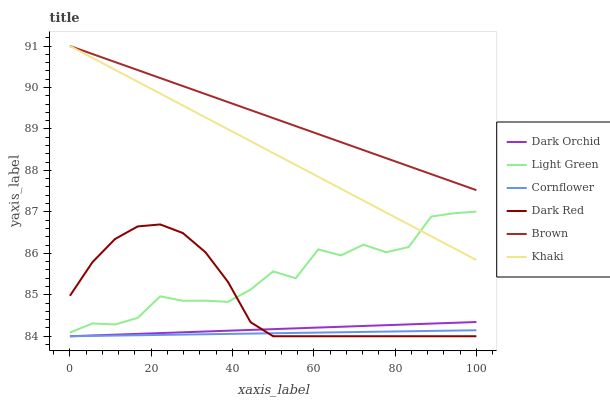Does Cornflower have the minimum area under the curve?
Answer yes or no. Yes. Does Brown have the maximum area under the curve?
Answer yes or no. Yes. Does Khaki have the minimum area under the curve?
Answer yes or no. No. Does Khaki have the maximum area under the curve?
Answer yes or no. No. Is Dark Orchid the smoothest?
Answer yes or no. Yes. Is Light Green the roughest?
Answer yes or no. Yes. Is Khaki the smoothest?
Answer yes or no. No. Is Khaki the roughest?
Answer yes or no. No. Does Cornflower have the lowest value?
Answer yes or no. Yes. Does Khaki have the lowest value?
Answer yes or no. No. Does Khaki have the highest value?
Answer yes or no. Yes. Does Cornflower have the highest value?
Answer yes or no. No. Is Dark Orchid less than Brown?
Answer yes or no. Yes. Is Brown greater than Dark Orchid?
Answer yes or no. Yes. Does Khaki intersect Brown?
Answer yes or no. Yes. Is Khaki less than Brown?
Answer yes or no. No. Is Khaki greater than Brown?
Answer yes or no. No. Does Dark Orchid intersect Brown?
Answer yes or no. No. 